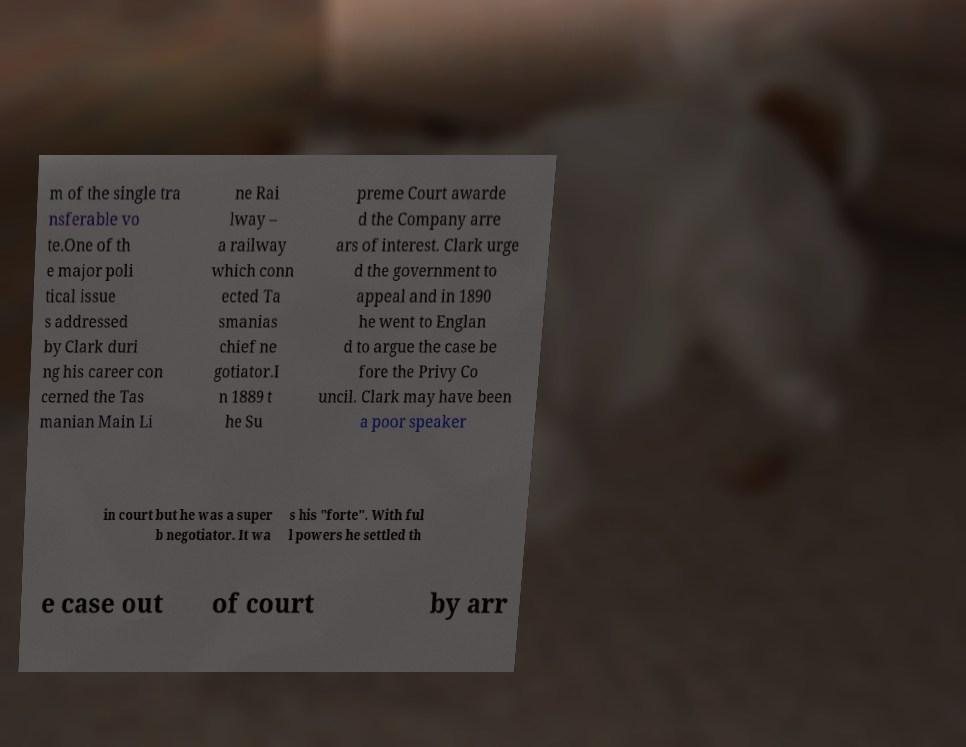Could you assist in decoding the text presented in this image and type it out clearly? m of the single tra nsferable vo te.One of th e major poli tical issue s addressed by Clark duri ng his career con cerned the Tas manian Main Li ne Rai lway – a railway which conn ected Ta smanias chief ne gotiator.I n 1889 t he Su preme Court awarde d the Company arre ars of interest. Clark urge d the government to appeal and in 1890 he went to Englan d to argue the case be fore the Privy Co uncil. Clark may have been a poor speaker in court but he was a super b negotiator. It wa s his "forte". With ful l powers he settled th e case out of court by arr 